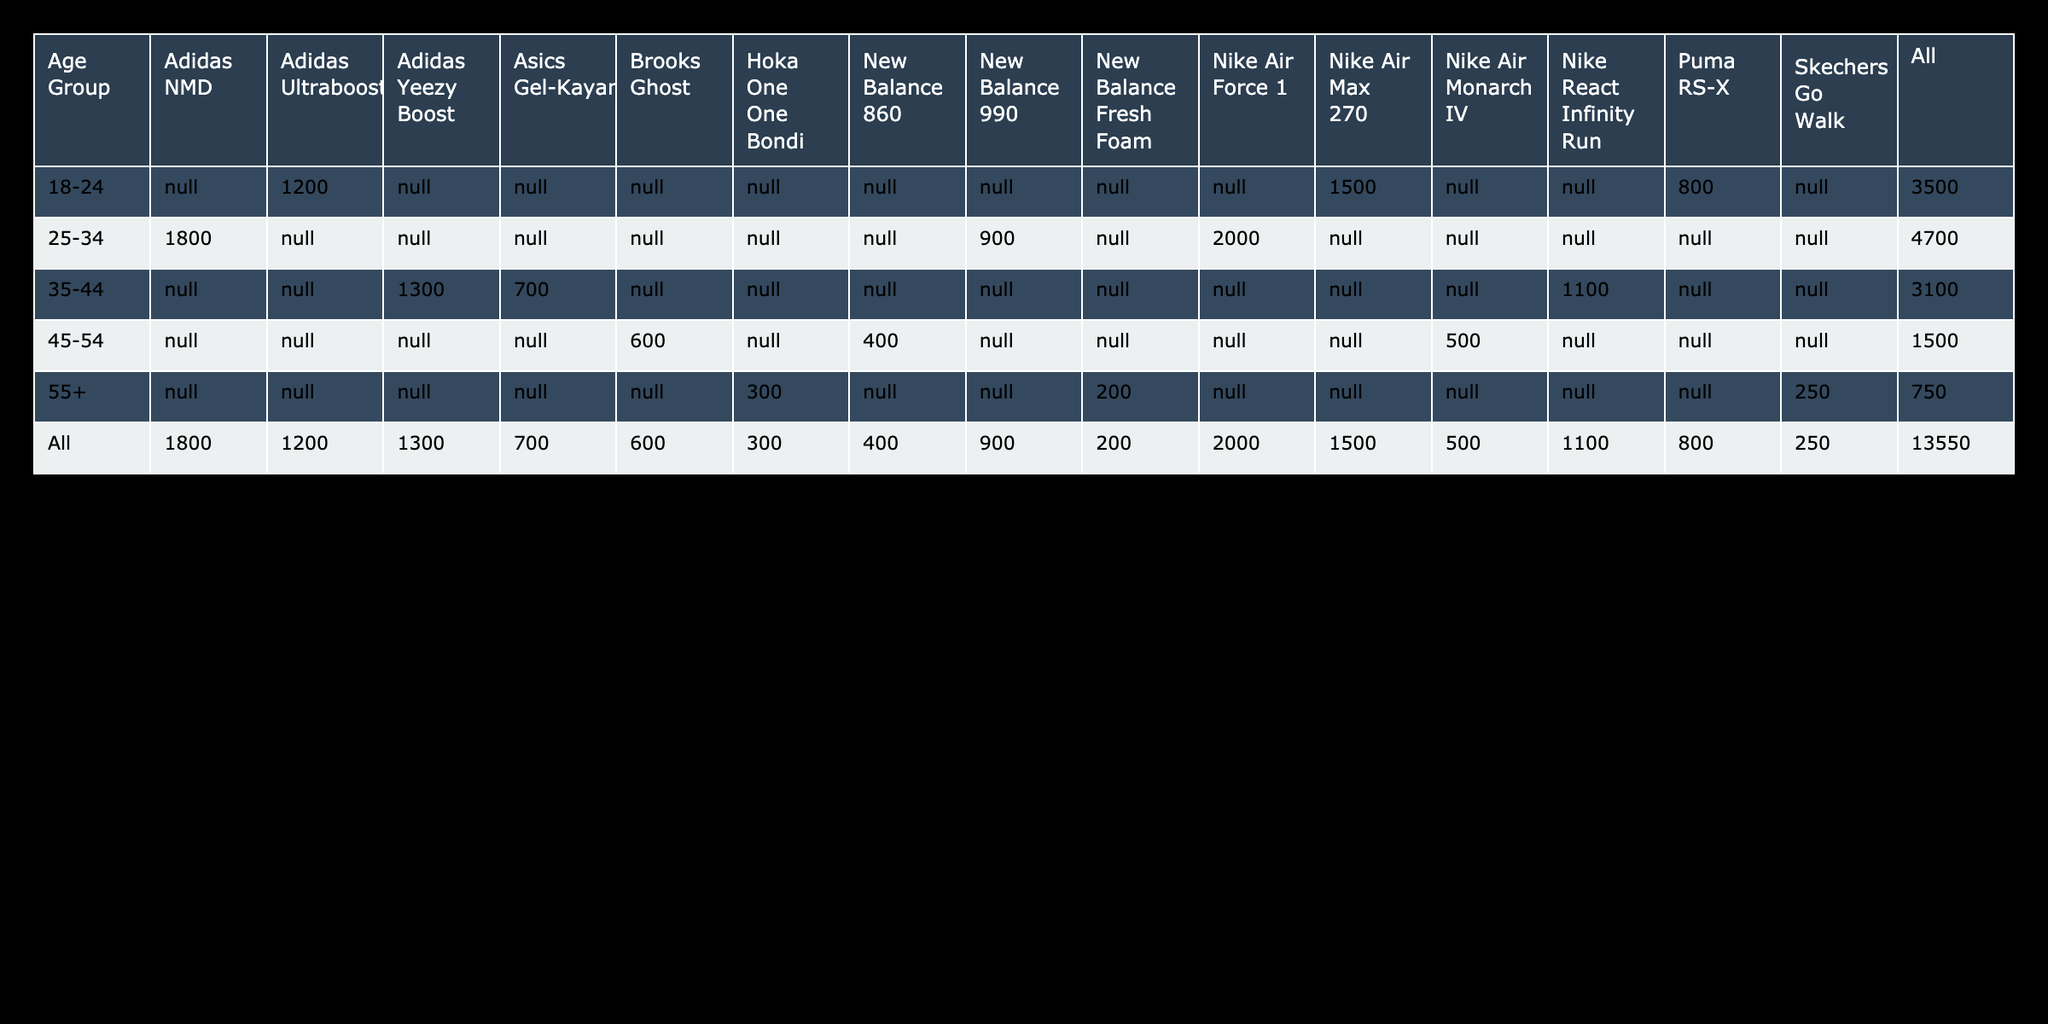What is the total sales volume for the Nike Air Max 270 in the age group 18-24? According to the table, the sales volume for the Nike Air Max 270 in the age group 18-24 is stated as 1500.
Answer: 1500 Which shoe design has the highest sales in the age group 25-34? From the data provided, the highest sales in the age group 25-34 is for the Nike Air Force 1, with a total sales volume of 2000.
Answer: Nike Air Force 1 Is the Adidas Yeezy Boost the best-selling shoe among all age groups? The table shows that the Adidas Yeezy Boost has a sales volume of 1300, which is less than the Nike Air Force 1 (2000) and the Nike Air Max 270 (1500), indicating that it is not the best-selling shoe overall.
Answer: No What is the difference in sales volume between the Adidas Ultraboost and the Puma RS-X in the age group 18-24? The sales volume for Adidas Ultraboost is 1200 and for Puma RS-X is 800. Therefore, the difference is 1200 - 800 = 400.
Answer: 400 What is the average sales volume for the new sneaker designs in the age group 55+? The sales volumes for the age group 55+ are Hoka One One Bondi (300), Skechers Go Walk (250), and New Balance Fresh Foam (200). Adding these gives 300 + 250 + 200 = 750. Dividing by the number of designs (3) gives an average of 750 / 3 = 250.
Answer: 250 What is the total sales volume for the Brooks Ghost and Nike Air Monarch IV combined? The sales volume for Brooks Ghost is 600 and for Nike Air Monarch IV is 500. Adding these gives a total of 600 + 500 = 1100.
Answer: 1100 Is the Puma RS-X more popular than New Balance 990 in the age group 25-34 based on sales volume? In the age group 25-34, Puma RS-X does not have sales data provided, while New Balance 990 has a sales volume of 900. Since we have no data on Puma RS-X, we cannot determine its popularity compared to New Balance 990.
Answer: Unknown Which age group has the least overall sales volume across all shoe designs? The sales volumes for the age group 55+ are Hoka One One Bondi (300), Skechers Go Walk (250), and New Balance Fresh Foam (200), totaling 750. This is less than the totals for other age groups, indicating that the 55+ age group has the least overall sales volume.
Answer: 55+ What shoe designs have sales lower than 600 in the age group 45-54? The shoe designs with sales lower than 600 in the age group 45-54 are Nike Air Monarch IV (500) and New Balance 860 (400).
Answer: Nike Air Monarch IV, New Balance 860 